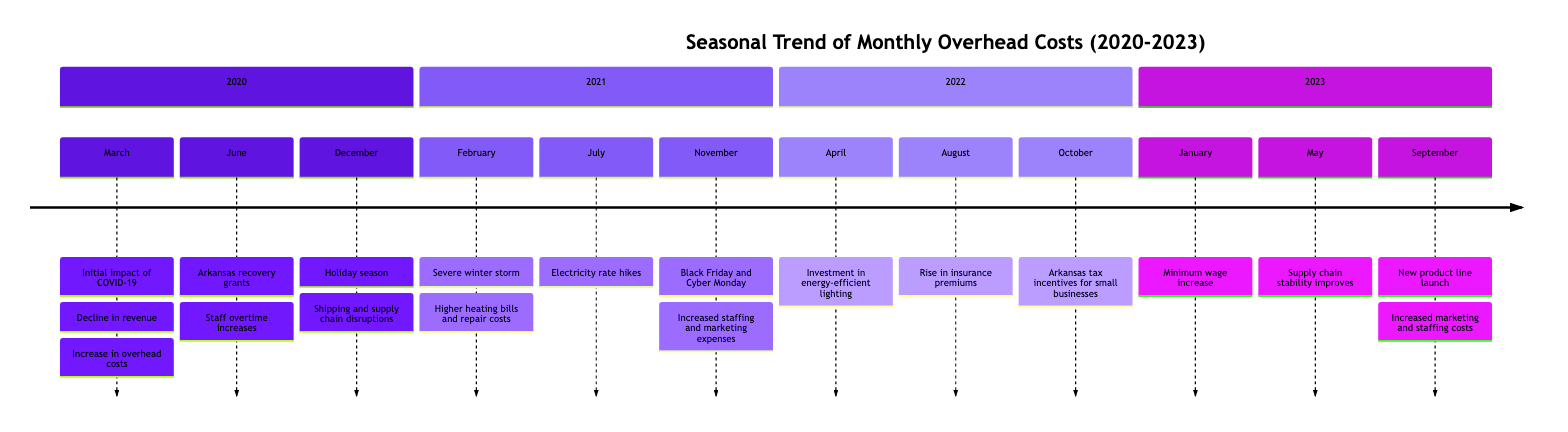What month in 2020 saw the initial impact of COVID-19? The timeline indicates that the initial impact of COVID-19 was noted in March 2020. Therefore, the answer is found by examining the events listed under the year 2020.
Answer: March Which event led to an increase in overhead costs in 2021? In 2021, the severe winter storm in February is identified as a specific event that resulted in higher heating bills and repair costs, directly affecting overhead. Thus, reviewing the events for the relevant year confirms this relationship.
Answer: Severe winter storm What happened in June 2020 that affected overhead costs? The event described in June 2020 is the implementation of recovery grants by the state of Arkansas. While this helped ease costs, it is noted that staff overtime began to increase due to the business picking back up. This shows both a positive and a negative impact on overhead costs.
Answer: Arkansas recovery grants How did overhead costs change in May 2023? In May 2023, supply chain stability improves, which is directly stated to reduce associated overhead costs. This indicates a shift to lower overhead due to improvements in supply logistics.
Answer: Reducing overhead costs In which month did electricity rate hikes occur, and in which year? The timeline specifies that electricity rate hikes occurred in July 2021. This information can be extracted by scanning the events listed for the year 2021, explicitly noting the impact on utility bills.
Answer: July 2021 What overall trend can be observed regarding overhead costs from 2020 to 2023? Analyzing the events across the four years reveals fluctuating overhead costs due to various economic and environmental factors. However, the introduction of Arkansas tax incentives in October 2022 and improvements in May 2023 suggest a general trend towards reduced overhead over time. This is a reasoning question that combines multiple data points from different months.
Answer: Fluctuating with improvements toward reduction What significant investment occurred in April 2022? The significant investment highlighted in April 2022 was in energy-efficient lighting, specifically aimed at reducing utility costs for the upcoming summer. This can be confirmed by reviewing the facts pertaining to 2022.
Answer: Energy-efficient lighting What promotional events in late 2021 contributed to increased costs? Reviewing November 2021, the Black Friday and Cyber Monday promotions are noted events that led to increased staffing costs and marketing expenses. This links specific promotional activities to overhead costs.
Answer: Black Friday and Cyber Monday promotions 